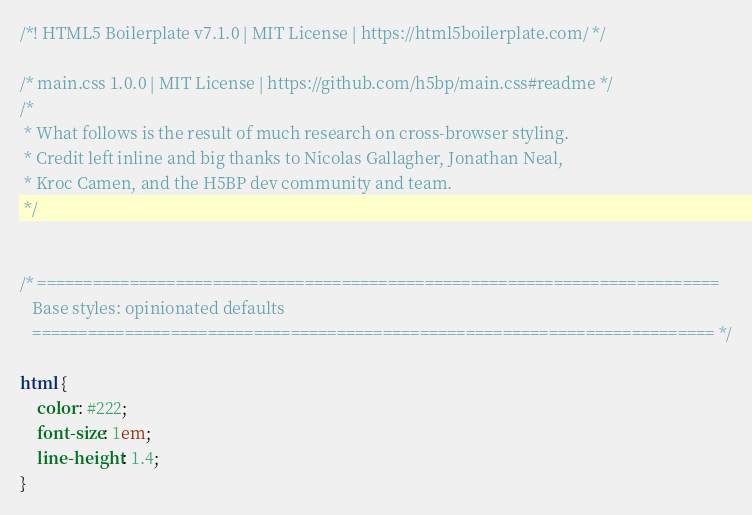<code> <loc_0><loc_0><loc_500><loc_500><_CSS_>/*! HTML5 Boilerplate v7.1.0 | MIT License | https://html5boilerplate.com/ */

/* main.css 1.0.0 | MIT License | https://github.com/h5bp/main.css#readme */
/*
 * What follows is the result of much research on cross-browser styling.
 * Credit left inline and big thanks to Nicolas Gallagher, Jonathan Neal,
 * Kroc Camen, and the H5BP dev community and team.
 */

 
/* ==========================================================================
   Base styles: opinionated defaults
   ========================================================================== */

html {
    color: #222;
    font-size: 1em;
    line-height: 1.4;
}
</code> 